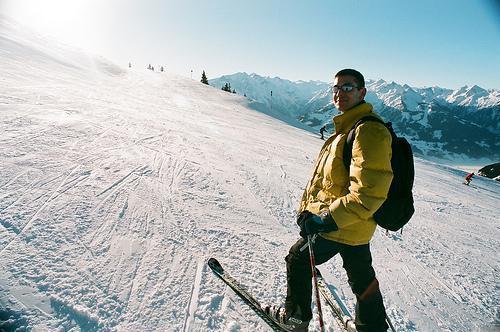How many people are in picture?
Give a very brief answer. 2. How many skis is the man in yellow jacket wearing?
Give a very brief answer. 2. 